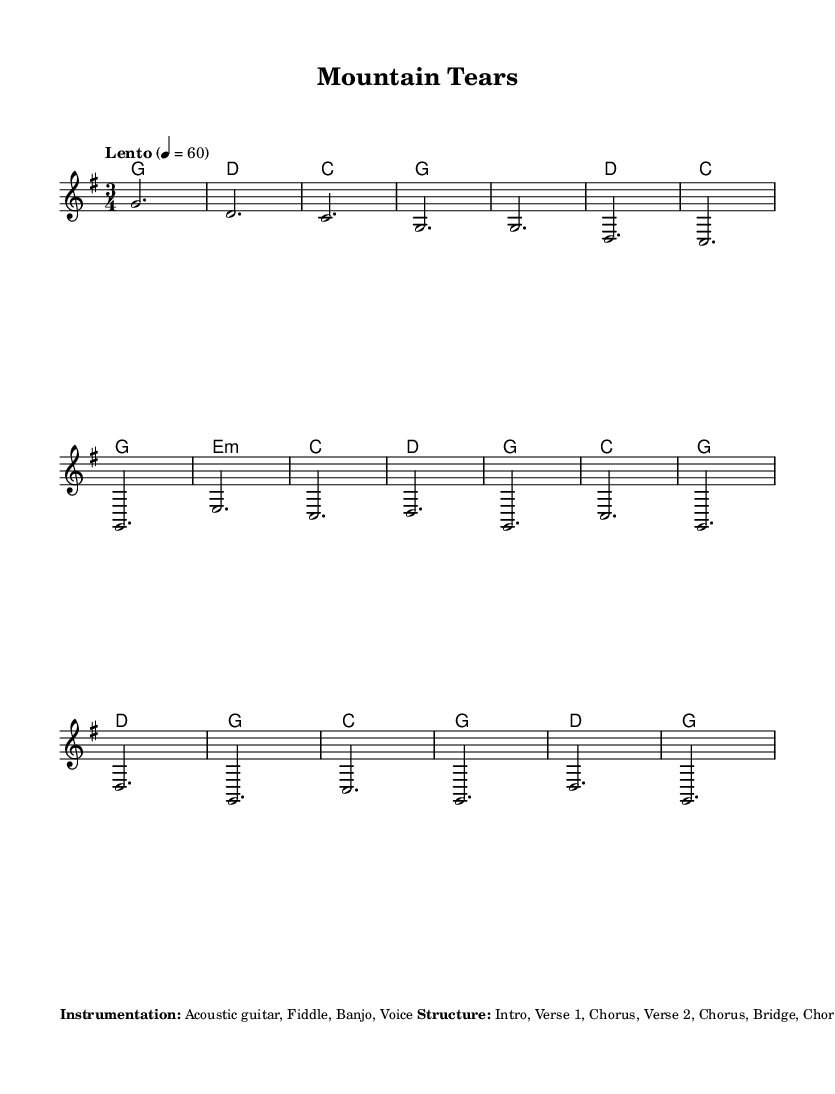What is the key signature of this music? The key signature is G major, which has one sharp (F#). This can be identified by looking at the key signature indicated at the beginning of the staff.
Answer: G major What is the time signature of this piece? The time signature is 3/4, which means there are three beats in a measure and the quarter note gets one beat. This is shown at the beginning of the sheet music.
Answer: 3/4 What is the tempo marking for this music? The tempo marking is "Lento," indicating a slow tempo. This is specified directly above the staff in the sheet music.
Answer: Lento How many sections are in the overall structure of the piece? The structure is composed of eight sections: Intro, Verse 1, Chorus, Verse 2, Chorus, Bridge, Chorus, and Outro. This breakdown is provided in the additional notes section of the sheet music.
Answer: Eight What instruments are included in the instrumentation for this piece? The instrumentation includes Acoustic guitar, Fiddle, Banjo, and Voice. This information is listed in the additional notes section where the instrumentation is explicitly stated.
Answer: Acoustic guitar, Fiddle, Banjo, Voice What arpeggio pattern does the banjo use? The banjo uses an eighth note arpeggio pattern. This detail is included in the rhythm section of the additional notes, where specific instrument roles and styles are described.
Answer: Eighth note arpeggios What vocal style is suggested for this piece? The suggested vocal style is raw and emotive, with slight bends on held notes. This is elaborated in the additional notes section regarding the vocal performance style.
Answer: Raw and emotive 